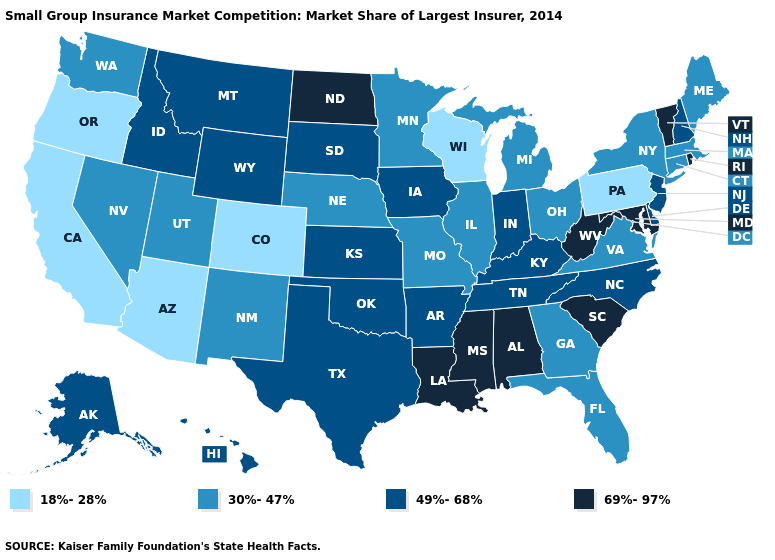Which states have the highest value in the USA?
Keep it brief. Alabama, Louisiana, Maryland, Mississippi, North Dakota, Rhode Island, South Carolina, Vermont, West Virginia. Does Delaware have a higher value than New Jersey?
Write a very short answer. No. What is the lowest value in states that border Montana?
Concise answer only. 49%-68%. Name the states that have a value in the range 18%-28%?
Quick response, please. Arizona, California, Colorado, Oregon, Pennsylvania, Wisconsin. Does Vermont have the same value as Alabama?
Short answer required. Yes. Among the states that border Florida , does Alabama have the highest value?
Quick response, please. Yes. Does Wyoming have the highest value in the West?
Give a very brief answer. Yes. What is the value of North Dakota?
Concise answer only. 69%-97%. Does New Hampshire have a lower value than Mississippi?
Be succinct. Yes. Does Illinois have a higher value than Utah?
Be succinct. No. Among the states that border New Hampshire , does Vermont have the lowest value?
Write a very short answer. No. What is the lowest value in states that border Maryland?
Short answer required. 18%-28%. Does Connecticut have the same value as Louisiana?
Write a very short answer. No. Name the states that have a value in the range 49%-68%?
Short answer required. Alaska, Arkansas, Delaware, Hawaii, Idaho, Indiana, Iowa, Kansas, Kentucky, Montana, New Hampshire, New Jersey, North Carolina, Oklahoma, South Dakota, Tennessee, Texas, Wyoming. 